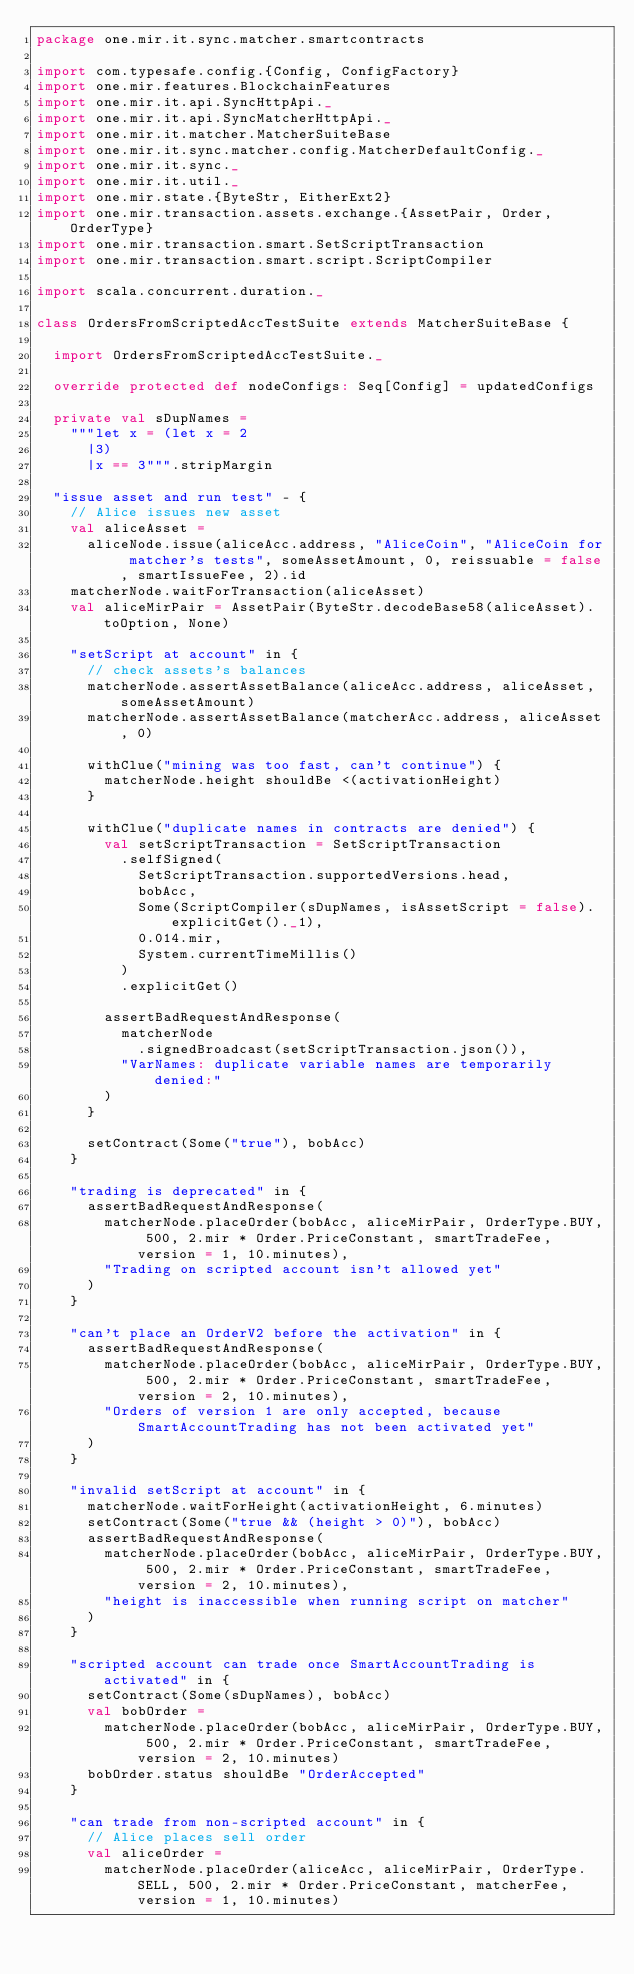<code> <loc_0><loc_0><loc_500><loc_500><_Scala_>package one.mir.it.sync.matcher.smartcontracts

import com.typesafe.config.{Config, ConfigFactory}
import one.mir.features.BlockchainFeatures
import one.mir.it.api.SyncHttpApi._
import one.mir.it.api.SyncMatcherHttpApi._
import one.mir.it.matcher.MatcherSuiteBase
import one.mir.it.sync.matcher.config.MatcherDefaultConfig._
import one.mir.it.sync._
import one.mir.it.util._
import one.mir.state.{ByteStr, EitherExt2}
import one.mir.transaction.assets.exchange.{AssetPair, Order, OrderType}
import one.mir.transaction.smart.SetScriptTransaction
import one.mir.transaction.smart.script.ScriptCompiler

import scala.concurrent.duration._

class OrdersFromScriptedAccTestSuite extends MatcherSuiteBase {

  import OrdersFromScriptedAccTestSuite._

  override protected def nodeConfigs: Seq[Config] = updatedConfigs

  private val sDupNames =
    """let x = (let x = 2
      |3)
      |x == 3""".stripMargin

  "issue asset and run test" - {
    // Alice issues new asset
    val aliceAsset =
      aliceNode.issue(aliceAcc.address, "AliceCoin", "AliceCoin for matcher's tests", someAssetAmount, 0, reissuable = false, smartIssueFee, 2).id
    matcherNode.waitForTransaction(aliceAsset)
    val aliceMirPair = AssetPair(ByteStr.decodeBase58(aliceAsset).toOption, None)

    "setScript at account" in {
      // check assets's balances
      matcherNode.assertAssetBalance(aliceAcc.address, aliceAsset, someAssetAmount)
      matcherNode.assertAssetBalance(matcherAcc.address, aliceAsset, 0)

      withClue("mining was too fast, can't continue") {
        matcherNode.height shouldBe <(activationHeight)
      }

      withClue("duplicate names in contracts are denied") {
        val setScriptTransaction = SetScriptTransaction
          .selfSigned(
            SetScriptTransaction.supportedVersions.head,
            bobAcc,
            Some(ScriptCompiler(sDupNames, isAssetScript = false).explicitGet()._1),
            0.014.mir,
            System.currentTimeMillis()
          )
          .explicitGet()

        assertBadRequestAndResponse(
          matcherNode
            .signedBroadcast(setScriptTransaction.json()),
          "VarNames: duplicate variable names are temporarily denied:"
        )
      }

      setContract(Some("true"), bobAcc)
    }

    "trading is deprecated" in {
      assertBadRequestAndResponse(
        matcherNode.placeOrder(bobAcc, aliceMirPair, OrderType.BUY, 500, 2.mir * Order.PriceConstant, smartTradeFee, version = 1, 10.minutes),
        "Trading on scripted account isn't allowed yet"
      )
    }

    "can't place an OrderV2 before the activation" in {
      assertBadRequestAndResponse(
        matcherNode.placeOrder(bobAcc, aliceMirPair, OrderType.BUY, 500, 2.mir * Order.PriceConstant, smartTradeFee, version = 2, 10.minutes),
        "Orders of version 1 are only accepted, because SmartAccountTrading has not been activated yet"
      )
    }

    "invalid setScript at account" in {
      matcherNode.waitForHeight(activationHeight, 6.minutes)
      setContract(Some("true && (height > 0)"), bobAcc)
      assertBadRequestAndResponse(
        matcherNode.placeOrder(bobAcc, aliceMirPair, OrderType.BUY, 500, 2.mir * Order.PriceConstant, smartTradeFee, version = 2, 10.minutes),
        "height is inaccessible when running script on matcher"
      )
    }

    "scripted account can trade once SmartAccountTrading is activated" in {
      setContract(Some(sDupNames), bobAcc)
      val bobOrder =
        matcherNode.placeOrder(bobAcc, aliceMirPair, OrderType.BUY, 500, 2.mir * Order.PriceConstant, smartTradeFee, version = 2, 10.minutes)
      bobOrder.status shouldBe "OrderAccepted"
    }

    "can trade from non-scripted account" in {
      // Alice places sell order
      val aliceOrder =
        matcherNode.placeOrder(aliceAcc, aliceMirPair, OrderType.SELL, 500, 2.mir * Order.PriceConstant, matcherFee, version = 1, 10.minutes)
</code> 